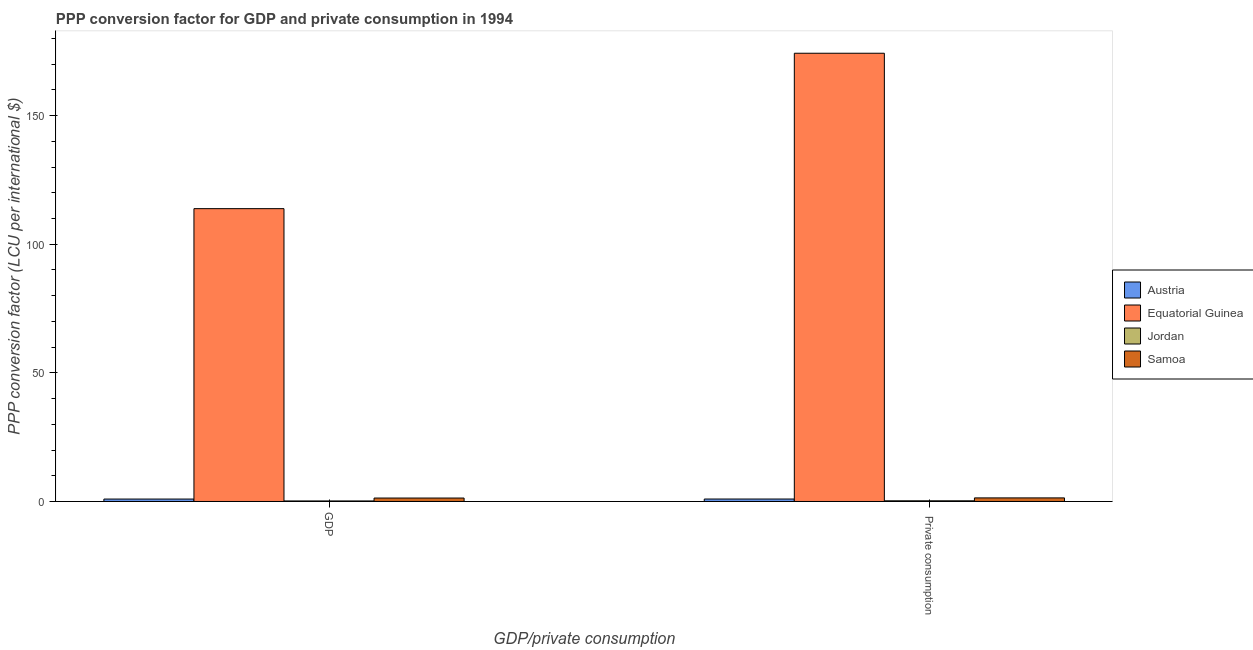Are the number of bars per tick equal to the number of legend labels?
Give a very brief answer. Yes. Are the number of bars on each tick of the X-axis equal?
Provide a succinct answer. Yes. What is the label of the 1st group of bars from the left?
Give a very brief answer. GDP. What is the ppp conversion factor for private consumption in Jordan?
Your answer should be very brief. 0.26. Across all countries, what is the maximum ppp conversion factor for gdp?
Your response must be concise. 113.82. Across all countries, what is the minimum ppp conversion factor for gdp?
Offer a terse response. 0.21. In which country was the ppp conversion factor for private consumption maximum?
Give a very brief answer. Equatorial Guinea. In which country was the ppp conversion factor for gdp minimum?
Your answer should be very brief. Jordan. What is the total ppp conversion factor for gdp in the graph?
Offer a very short reply. 116.3. What is the difference between the ppp conversion factor for private consumption in Austria and that in Jordan?
Your answer should be compact. 0.69. What is the difference between the ppp conversion factor for private consumption in Austria and the ppp conversion factor for gdp in Samoa?
Offer a terse response. -0.38. What is the average ppp conversion factor for gdp per country?
Keep it short and to the point. 29.07. What is the difference between the ppp conversion factor for private consumption and ppp conversion factor for gdp in Equatorial Guinea?
Make the answer very short. 60.41. In how many countries, is the ppp conversion factor for private consumption greater than 50 LCU?
Ensure brevity in your answer.  1. What is the ratio of the ppp conversion factor for private consumption in Samoa to that in Equatorial Guinea?
Keep it short and to the point. 0.01. What does the 3rd bar from the left in GDP represents?
Provide a short and direct response. Jordan. What does the 2nd bar from the right in  Private consumption represents?
Your answer should be compact. Jordan. How many countries are there in the graph?
Your answer should be compact. 4. Does the graph contain any zero values?
Provide a short and direct response. No. Does the graph contain grids?
Your answer should be very brief. No. Where does the legend appear in the graph?
Offer a terse response. Center right. How many legend labels are there?
Ensure brevity in your answer.  4. What is the title of the graph?
Provide a succinct answer. PPP conversion factor for GDP and private consumption in 1994. Does "Ethiopia" appear as one of the legend labels in the graph?
Offer a very short reply. No. What is the label or title of the X-axis?
Provide a succinct answer. GDP/private consumption. What is the label or title of the Y-axis?
Your answer should be compact. PPP conversion factor (LCU per international $). What is the PPP conversion factor (LCU per international $) in Austria in GDP?
Offer a terse response. 0.94. What is the PPP conversion factor (LCU per international $) in Equatorial Guinea in GDP?
Ensure brevity in your answer.  113.82. What is the PPP conversion factor (LCU per international $) of Jordan in GDP?
Provide a short and direct response. 0.21. What is the PPP conversion factor (LCU per international $) in Samoa in GDP?
Offer a very short reply. 1.34. What is the PPP conversion factor (LCU per international $) in Austria in  Private consumption?
Provide a short and direct response. 0.95. What is the PPP conversion factor (LCU per international $) in Equatorial Guinea in  Private consumption?
Your response must be concise. 174.23. What is the PPP conversion factor (LCU per international $) in Jordan in  Private consumption?
Offer a very short reply. 0.26. What is the PPP conversion factor (LCU per international $) in Samoa in  Private consumption?
Make the answer very short. 1.39. Across all GDP/private consumption, what is the maximum PPP conversion factor (LCU per international $) of Austria?
Your answer should be very brief. 0.95. Across all GDP/private consumption, what is the maximum PPP conversion factor (LCU per international $) of Equatorial Guinea?
Ensure brevity in your answer.  174.23. Across all GDP/private consumption, what is the maximum PPP conversion factor (LCU per international $) of Jordan?
Your answer should be compact. 0.26. Across all GDP/private consumption, what is the maximum PPP conversion factor (LCU per international $) of Samoa?
Provide a succinct answer. 1.39. Across all GDP/private consumption, what is the minimum PPP conversion factor (LCU per international $) of Austria?
Ensure brevity in your answer.  0.94. Across all GDP/private consumption, what is the minimum PPP conversion factor (LCU per international $) of Equatorial Guinea?
Give a very brief answer. 113.82. Across all GDP/private consumption, what is the minimum PPP conversion factor (LCU per international $) in Jordan?
Provide a succinct answer. 0.21. Across all GDP/private consumption, what is the minimum PPP conversion factor (LCU per international $) of Samoa?
Keep it short and to the point. 1.34. What is the total PPP conversion factor (LCU per international $) of Austria in the graph?
Provide a succinct answer. 1.89. What is the total PPP conversion factor (LCU per international $) of Equatorial Guinea in the graph?
Your response must be concise. 288.05. What is the total PPP conversion factor (LCU per international $) in Jordan in the graph?
Your answer should be compact. 0.47. What is the total PPP conversion factor (LCU per international $) of Samoa in the graph?
Keep it short and to the point. 2.73. What is the difference between the PPP conversion factor (LCU per international $) of Austria in GDP and that in  Private consumption?
Your answer should be compact. -0.02. What is the difference between the PPP conversion factor (LCU per international $) of Equatorial Guinea in GDP and that in  Private consumption?
Provide a succinct answer. -60.41. What is the difference between the PPP conversion factor (LCU per international $) in Jordan in GDP and that in  Private consumption?
Give a very brief answer. -0.06. What is the difference between the PPP conversion factor (LCU per international $) of Samoa in GDP and that in  Private consumption?
Offer a very short reply. -0.06. What is the difference between the PPP conversion factor (LCU per international $) in Austria in GDP and the PPP conversion factor (LCU per international $) in Equatorial Guinea in  Private consumption?
Offer a very short reply. -173.3. What is the difference between the PPP conversion factor (LCU per international $) of Austria in GDP and the PPP conversion factor (LCU per international $) of Jordan in  Private consumption?
Make the answer very short. 0.67. What is the difference between the PPP conversion factor (LCU per international $) in Austria in GDP and the PPP conversion factor (LCU per international $) in Samoa in  Private consumption?
Keep it short and to the point. -0.45. What is the difference between the PPP conversion factor (LCU per international $) of Equatorial Guinea in GDP and the PPP conversion factor (LCU per international $) of Jordan in  Private consumption?
Your response must be concise. 113.56. What is the difference between the PPP conversion factor (LCU per international $) in Equatorial Guinea in GDP and the PPP conversion factor (LCU per international $) in Samoa in  Private consumption?
Give a very brief answer. 112.43. What is the difference between the PPP conversion factor (LCU per international $) of Jordan in GDP and the PPP conversion factor (LCU per international $) of Samoa in  Private consumption?
Give a very brief answer. -1.19. What is the average PPP conversion factor (LCU per international $) in Austria per GDP/private consumption?
Offer a terse response. 0.94. What is the average PPP conversion factor (LCU per international $) in Equatorial Guinea per GDP/private consumption?
Your answer should be very brief. 144.03. What is the average PPP conversion factor (LCU per international $) in Jordan per GDP/private consumption?
Your response must be concise. 0.23. What is the average PPP conversion factor (LCU per international $) of Samoa per GDP/private consumption?
Provide a short and direct response. 1.36. What is the difference between the PPP conversion factor (LCU per international $) in Austria and PPP conversion factor (LCU per international $) in Equatorial Guinea in GDP?
Provide a succinct answer. -112.89. What is the difference between the PPP conversion factor (LCU per international $) of Austria and PPP conversion factor (LCU per international $) of Jordan in GDP?
Provide a succinct answer. 0.73. What is the difference between the PPP conversion factor (LCU per international $) of Austria and PPP conversion factor (LCU per international $) of Samoa in GDP?
Keep it short and to the point. -0.4. What is the difference between the PPP conversion factor (LCU per international $) in Equatorial Guinea and PPP conversion factor (LCU per international $) in Jordan in GDP?
Offer a terse response. 113.62. What is the difference between the PPP conversion factor (LCU per international $) of Equatorial Guinea and PPP conversion factor (LCU per international $) of Samoa in GDP?
Offer a terse response. 112.49. What is the difference between the PPP conversion factor (LCU per international $) of Jordan and PPP conversion factor (LCU per international $) of Samoa in GDP?
Provide a succinct answer. -1.13. What is the difference between the PPP conversion factor (LCU per international $) of Austria and PPP conversion factor (LCU per international $) of Equatorial Guinea in  Private consumption?
Keep it short and to the point. -173.28. What is the difference between the PPP conversion factor (LCU per international $) of Austria and PPP conversion factor (LCU per international $) of Jordan in  Private consumption?
Your answer should be compact. 0.69. What is the difference between the PPP conversion factor (LCU per international $) in Austria and PPP conversion factor (LCU per international $) in Samoa in  Private consumption?
Ensure brevity in your answer.  -0.44. What is the difference between the PPP conversion factor (LCU per international $) of Equatorial Guinea and PPP conversion factor (LCU per international $) of Jordan in  Private consumption?
Your answer should be very brief. 173.97. What is the difference between the PPP conversion factor (LCU per international $) in Equatorial Guinea and PPP conversion factor (LCU per international $) in Samoa in  Private consumption?
Offer a very short reply. 172.84. What is the difference between the PPP conversion factor (LCU per international $) of Jordan and PPP conversion factor (LCU per international $) of Samoa in  Private consumption?
Provide a succinct answer. -1.13. What is the ratio of the PPP conversion factor (LCU per international $) in Austria in GDP to that in  Private consumption?
Ensure brevity in your answer.  0.98. What is the ratio of the PPP conversion factor (LCU per international $) in Equatorial Guinea in GDP to that in  Private consumption?
Provide a succinct answer. 0.65. What is the ratio of the PPP conversion factor (LCU per international $) of Jordan in GDP to that in  Private consumption?
Give a very brief answer. 0.79. What is the ratio of the PPP conversion factor (LCU per international $) of Samoa in GDP to that in  Private consumption?
Keep it short and to the point. 0.96. What is the difference between the highest and the second highest PPP conversion factor (LCU per international $) in Austria?
Keep it short and to the point. 0.02. What is the difference between the highest and the second highest PPP conversion factor (LCU per international $) in Equatorial Guinea?
Give a very brief answer. 60.41. What is the difference between the highest and the second highest PPP conversion factor (LCU per international $) of Jordan?
Give a very brief answer. 0.06. What is the difference between the highest and the second highest PPP conversion factor (LCU per international $) in Samoa?
Your answer should be very brief. 0.06. What is the difference between the highest and the lowest PPP conversion factor (LCU per international $) of Austria?
Ensure brevity in your answer.  0.02. What is the difference between the highest and the lowest PPP conversion factor (LCU per international $) of Equatorial Guinea?
Your answer should be very brief. 60.41. What is the difference between the highest and the lowest PPP conversion factor (LCU per international $) in Jordan?
Your answer should be compact. 0.06. What is the difference between the highest and the lowest PPP conversion factor (LCU per international $) in Samoa?
Provide a short and direct response. 0.06. 